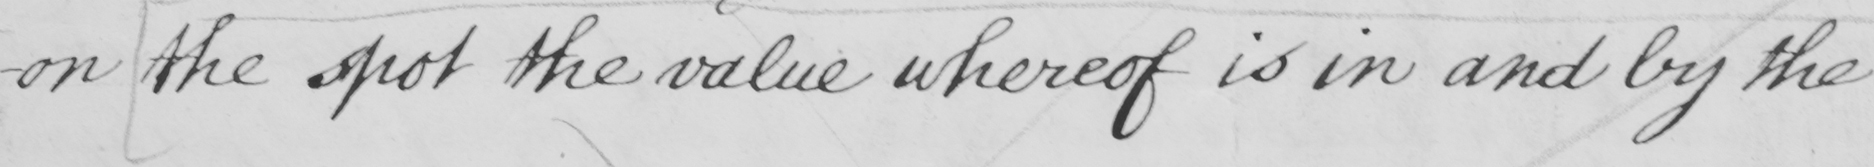What does this handwritten line say? -on the spot the value whereof is in and by the 